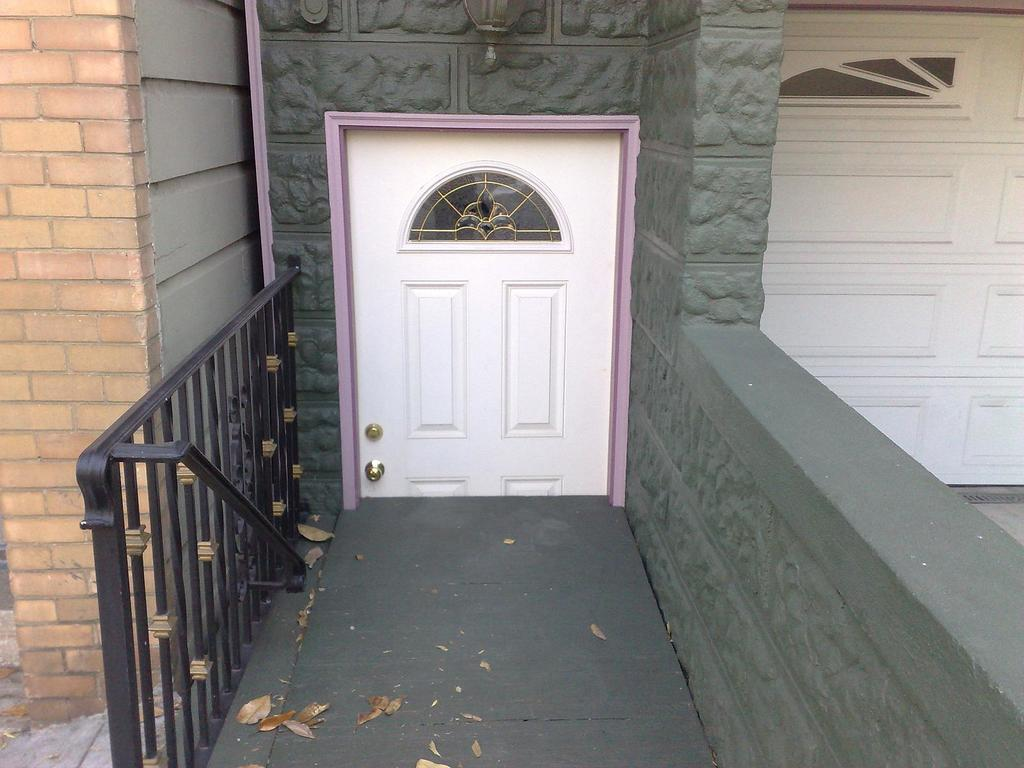What is located in the foreground of the image? There is a fence, a door, and a wall in the foreground of the image. Can you describe the lighting conditions in the image? The image was taken during the day, so there is natural light present. How many cows can be seen grazing in the rainstorm in the image? There are no cows or rainstorm present in the image; it features a fence, door, and wall in the foreground. 